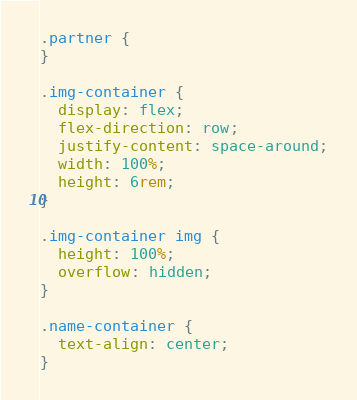Convert code to text. <code><loc_0><loc_0><loc_500><loc_500><_CSS_>.partner {
}

.img-container {
  display: flex;
  flex-direction: row;
  justify-content: space-around;
  width: 100%;
  height: 6rem;
}

.img-container img {
  height: 100%;
  overflow: hidden;
}

.name-container {
  text-align: center;
}
</code> 